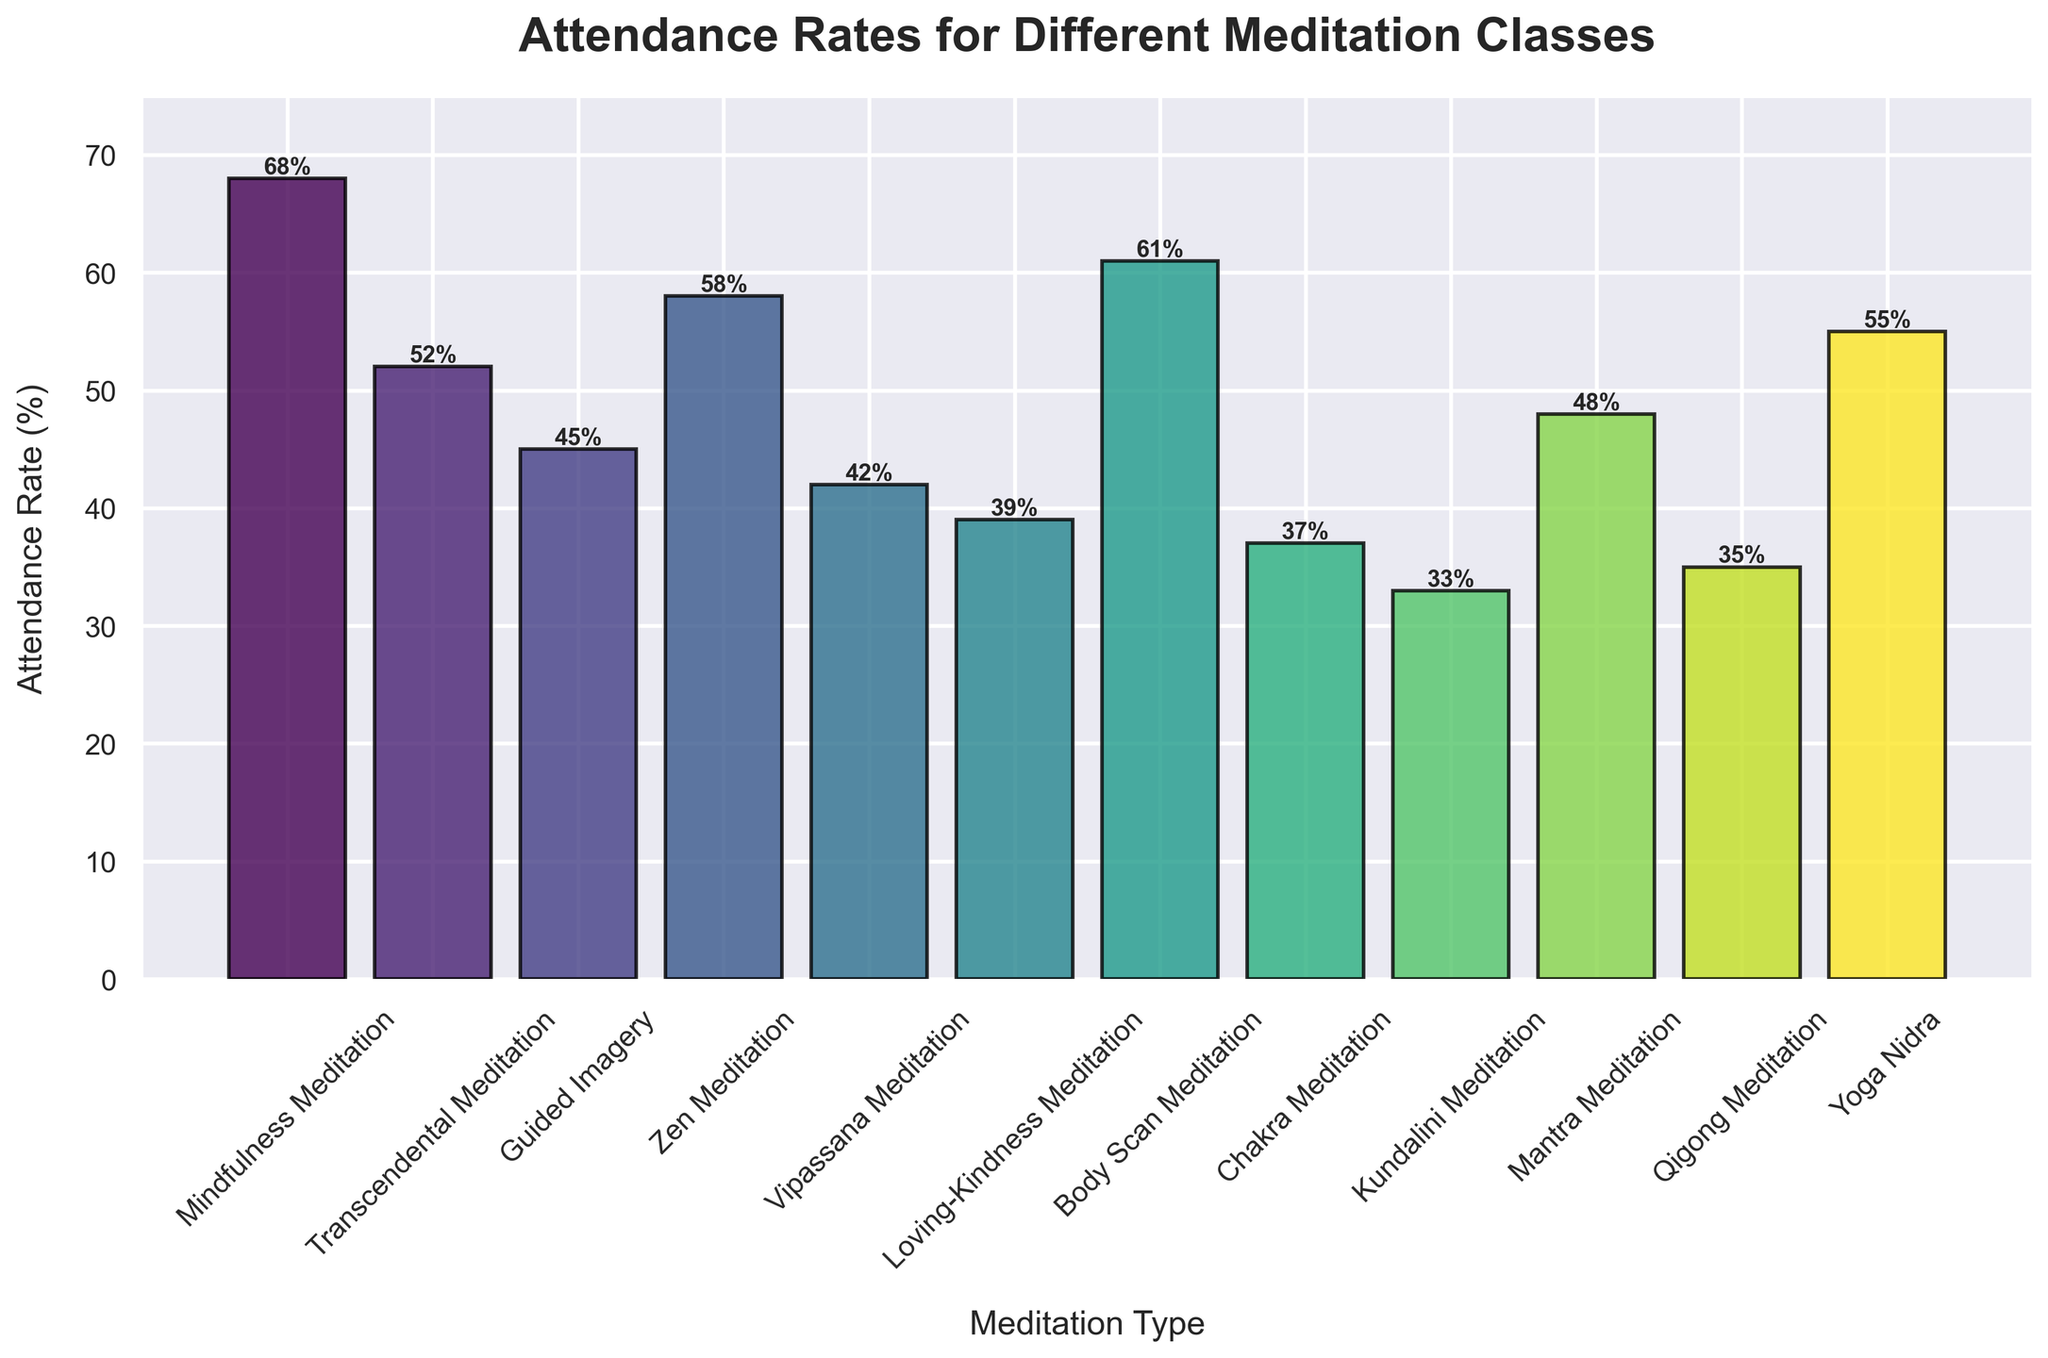What's the attendance rate for the class with the highest rate? The class with the highest attendance rate is the one with the tallest bar, which is Mindfulness Meditation at 68%.
Answer: 68% How many classes have an attendance rate above 50%? To find the number of classes above 50%, count the bars that extend beyond the 50% mark. The classes are Mindfulness Meditation (68%), Transcendental Meditation (52%), Zen Meditation (58%), Body Scan Meditation (61%), and Yoga Nidra (55%).
Answer: 5 What is the range of attendance rates for all the classes? The range is the difference between the highest and lowest attendance rates. The highest rate is 68% (Mindfulness Meditation) and the lowest is 33% (Kundalini Meditation). The range is 68% - 33% = 35%.
Answer: 35% Which type of meditation has the second lowest attendance rate? To determine the second lowest, arrange the rates in ascending order. Kundalini Meditation has the lowest rate at 33%, and the second lowest is Chakra Meditation at 37%.
Answer: Chakra Meditation What is the average attendance rate for all the meditation classes? Sum all the attendance rates and divide by the number of classes. (68 + 52 + 45 + 58 + 42 + 39 + 61 + 37 + 33 + 48 + 35 + 55) / 12 = 573 / 12 ≈ 47.75%.
Answer: 47.75% How does the attendance rate for Zen Meditation compare to Yoga Nidra? Find the rates for both classes. Zen Meditation has an attendance rate of 58% and Yoga Nidra has 55%. Zen Meditation has a higher attendance rate.
Answer: Zen Meditation Which meditation type has the most vibrant colored bar? Since the colors are mapped using a gradient from the viridis colormap, the most vibrant color (brightest yellow-green) usually represents the highest value. The Mindfulness Meditation bar, being the highest, is likely the most vibrant.
Answer: Mindfulness Meditation Are there more classes with attendance rates below or above 45%? Count the classes below 45% (Guided Imagery, Vipassana, Loving-Kindness, Chakra, Kundalini, Qigong) and above 45% (Mindfulness, Transcendental, Zen, Body Scan, Mantra, Yoga Nidra). There are 6 below and 6 above.
Answer: Equal What is the combined attendance rate for the three types of meditation with the highest rates? Identify and sum the top three rates: Mindfulness Meditation (68%), Body Scan Meditation (61%), and Zen Meditation (58%). The combined rate is 68 + 61 + 58 = 187%.
Answer: 187% Which bar represents Loving-Kindness Meditation, and how does its attendance rate compare to Zen Meditation? Find the Loving-Kindness Meditation bar (attendance rate 39%) and compare to Zen Meditation (rate 58%). Zen Meditation has a higher attendance rate.
Answer: Zen Meditation 